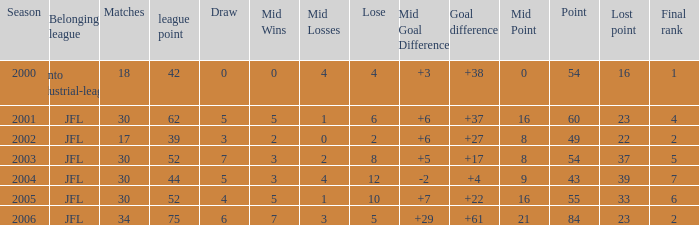Tell me the highest matches for point 43 and final rank less than 7 None. 